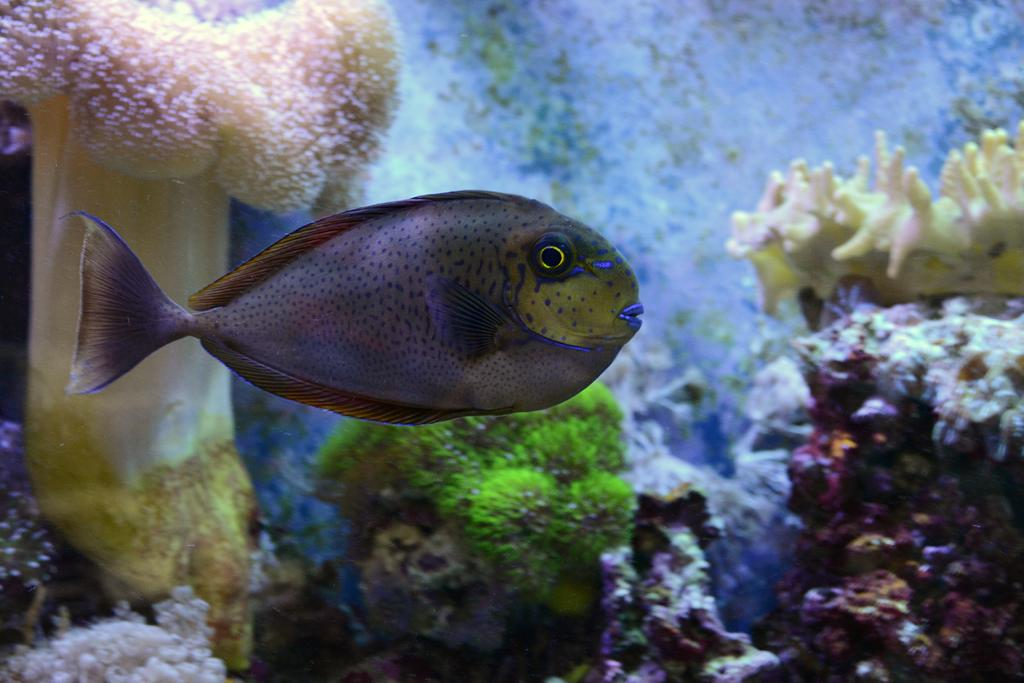What is the main subject of the image? There is a fish swimming in the water body. How close is the focus of the image? The image is zoomed in. What can be seen in the background of the image? There are marine creatures and marine plants in the background. How does the boy in the image feel about the harmony of the marine creatures? There is no boy present in the image, so it is not possible to determine how he feels about the harmony of the marine creatures. 